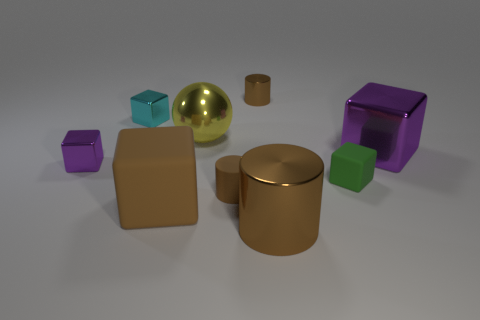What colors are the cubes in the image? The cubes present in the image showcase various colors including blue, purple, and green. Which object is the largest? The largest object appears to be the gold cylinder, which has the most substantial volume in comparison to the other objects. 